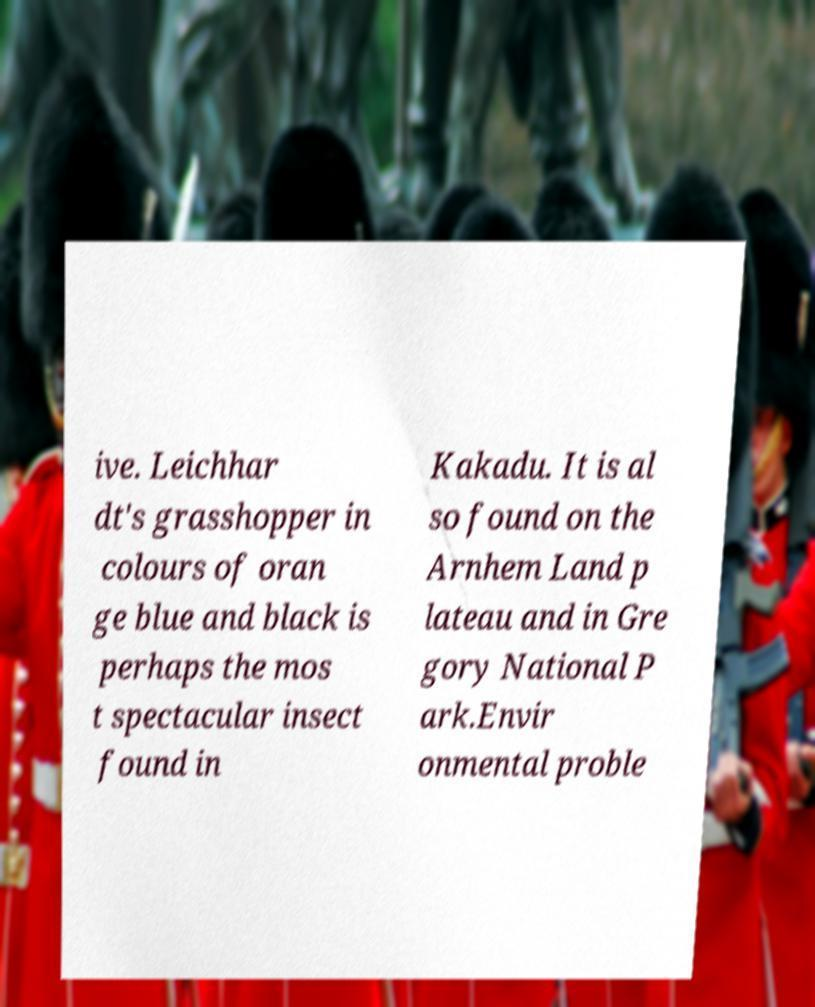Can you read and provide the text displayed in the image?This photo seems to have some interesting text. Can you extract and type it out for me? ive. Leichhar dt's grasshopper in colours of oran ge blue and black is perhaps the mos t spectacular insect found in Kakadu. It is al so found on the Arnhem Land p lateau and in Gre gory National P ark.Envir onmental proble 